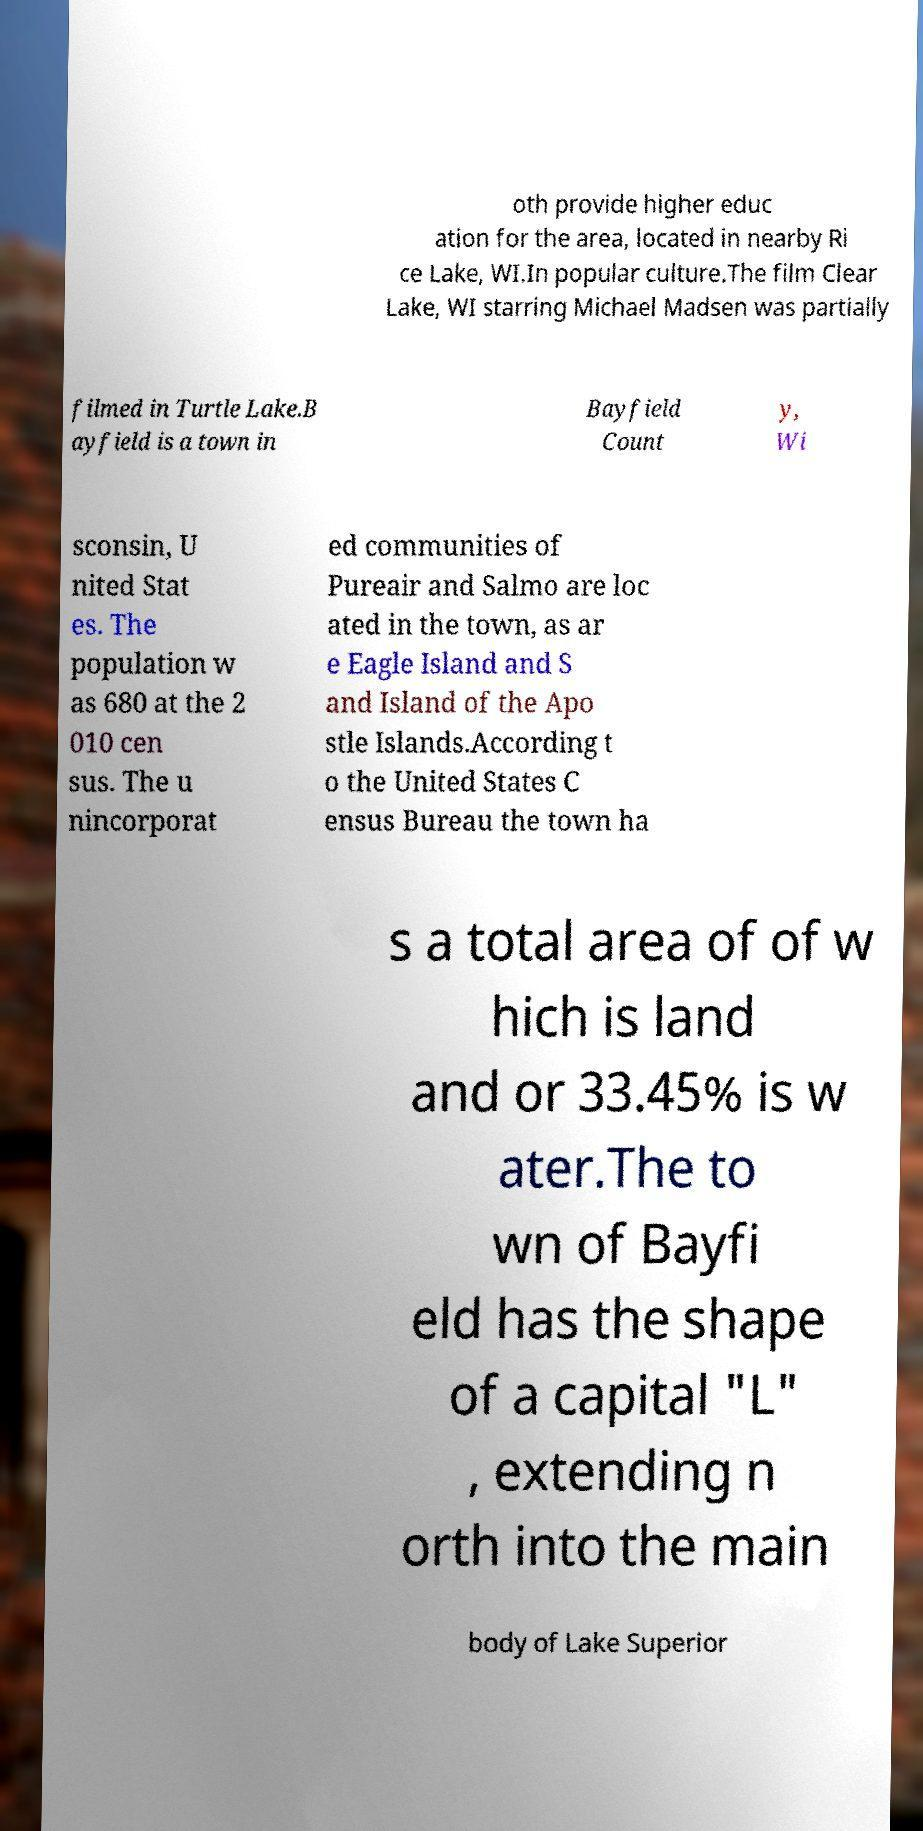I need the written content from this picture converted into text. Can you do that? oth provide higher educ ation for the area, located in nearby Ri ce Lake, WI.In popular culture.The film Clear Lake, WI starring Michael Madsen was partially filmed in Turtle Lake.B ayfield is a town in Bayfield Count y, Wi sconsin, U nited Stat es. The population w as 680 at the 2 010 cen sus. The u nincorporat ed communities of Pureair and Salmo are loc ated in the town, as ar e Eagle Island and S and Island of the Apo stle Islands.According t o the United States C ensus Bureau the town ha s a total area of of w hich is land and or 33.45% is w ater.The to wn of Bayfi eld has the shape of a capital "L" , extending n orth into the main body of Lake Superior 